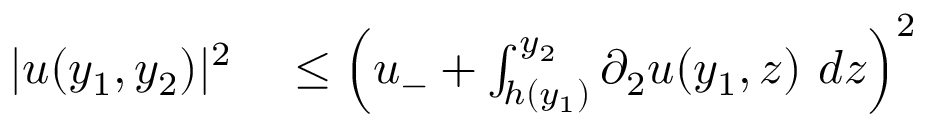Convert formula to latex. <formula><loc_0><loc_0><loc_500><loc_500>\begin{array} { r l } { | u ( y _ { 1 } , y _ { 2 } ) | ^ { 2 } } & \leq \left ( u _ { - } + \int _ { h ( y _ { 1 } ) } ^ { y _ { 2 } } \partial _ { 2 } u ( y _ { 1 } , z ) \ d z \right ) ^ { 2 } } \end{array}</formula> 